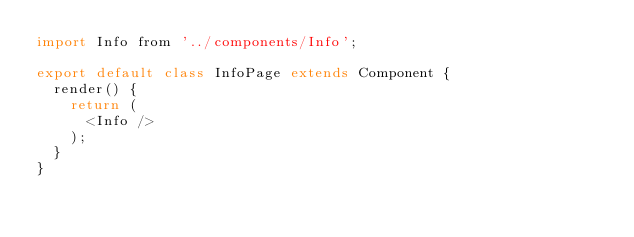<code> <loc_0><loc_0><loc_500><loc_500><_JavaScript_>import Info from '../components/Info';

export default class InfoPage extends Component {
  render() {
    return (
      <Info />
    );
  }
}
</code> 